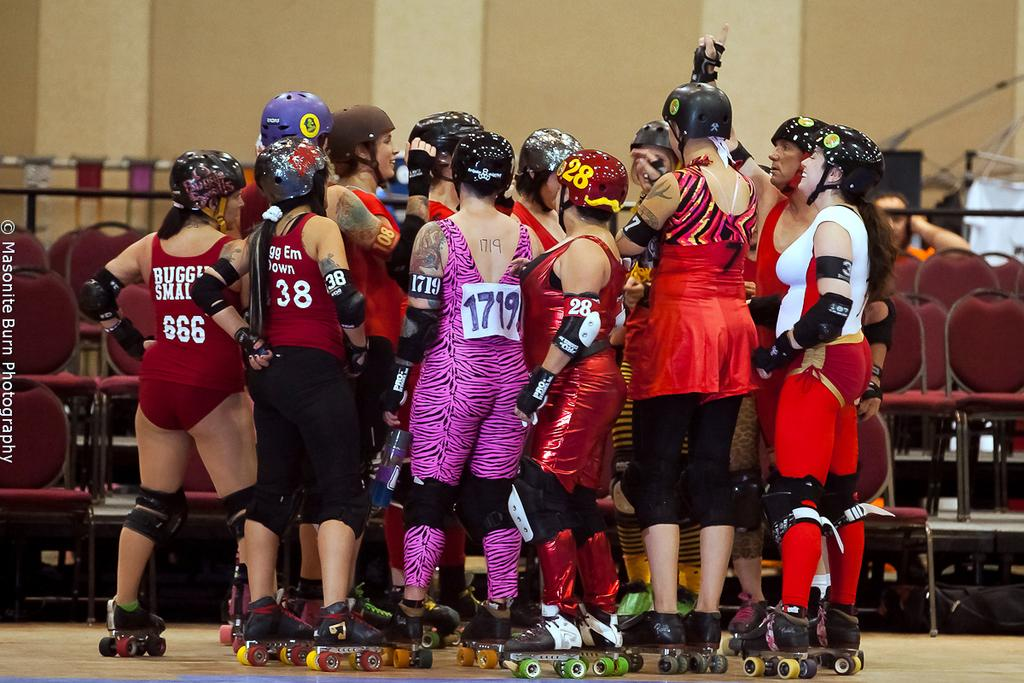<image>
Write a terse but informative summary of the picture. 1719 wears purple zebra in a group with other roller skaters 